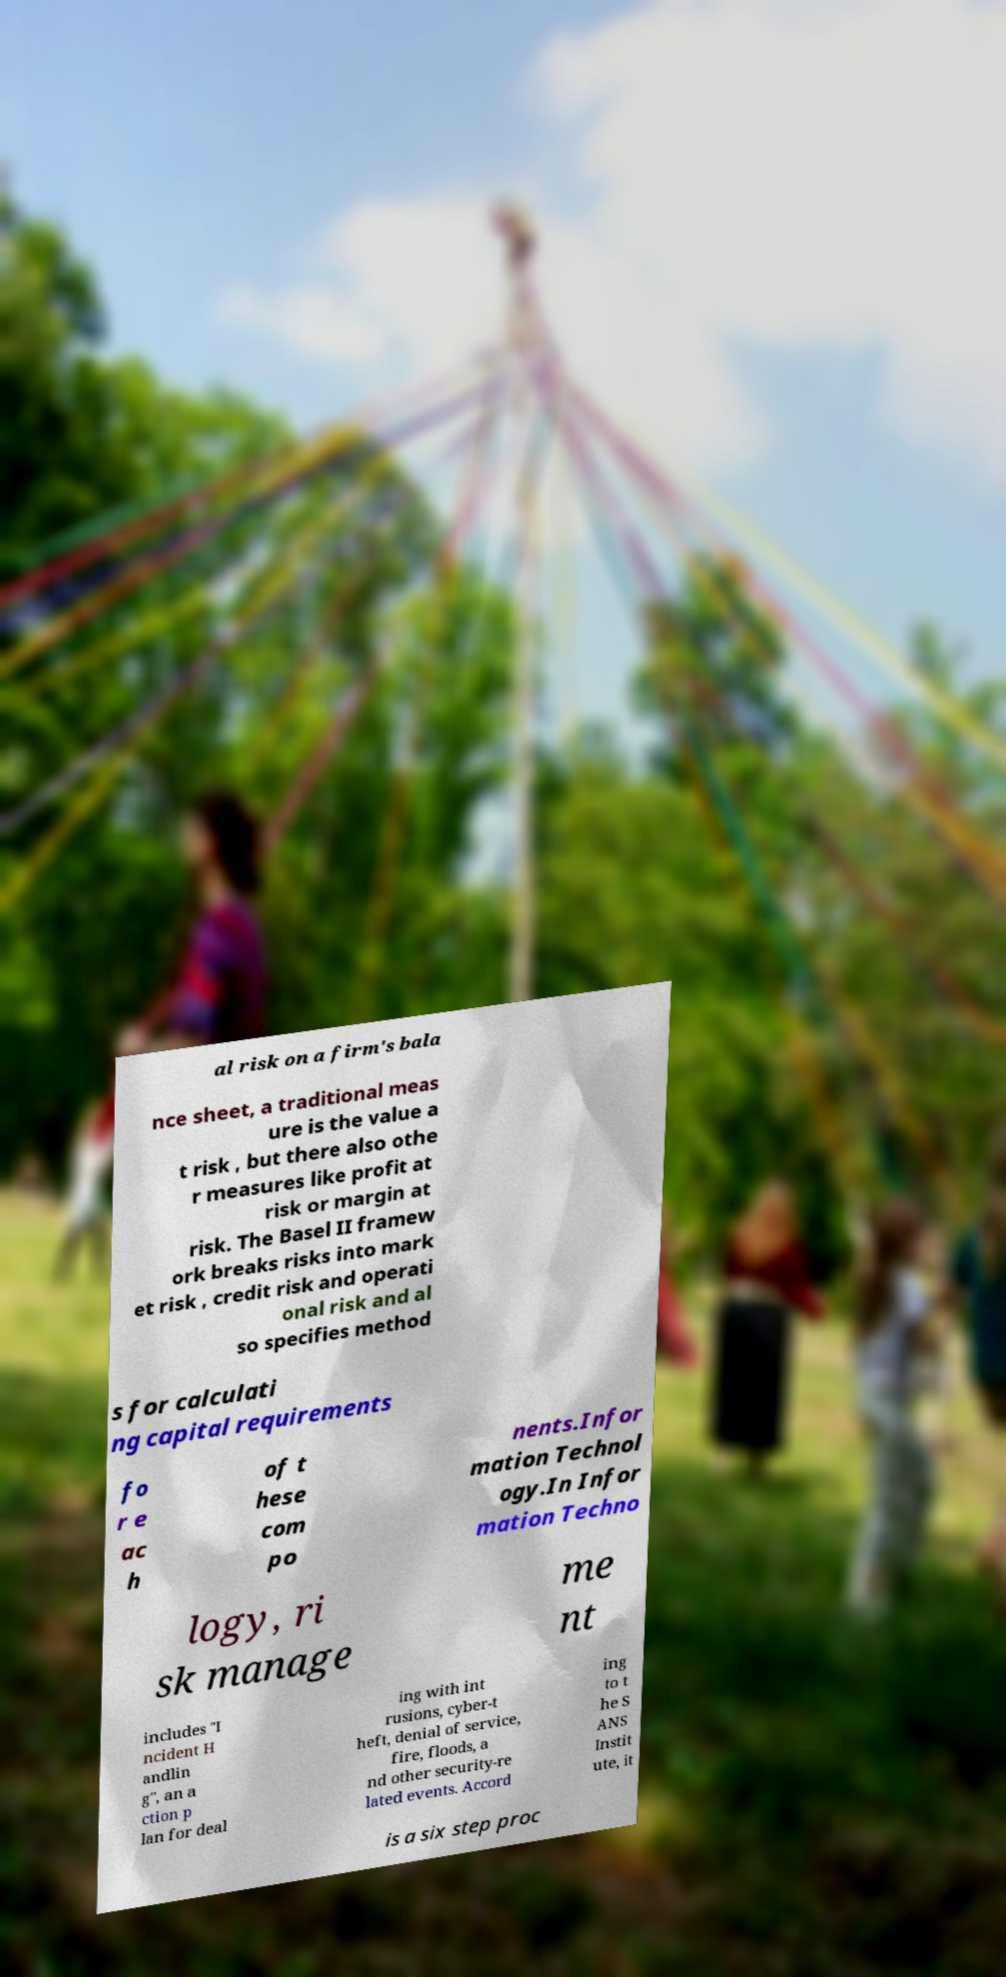For documentation purposes, I need the text within this image transcribed. Could you provide that? al risk on a firm's bala nce sheet, a traditional meas ure is the value a t risk , but there also othe r measures like profit at risk or margin at risk. The Basel II framew ork breaks risks into mark et risk , credit risk and operati onal risk and al so specifies method s for calculati ng capital requirements fo r e ac h of t hese com po nents.Infor mation Technol ogy.In Infor mation Techno logy, ri sk manage me nt includes "I ncident H andlin g", an a ction p lan for deal ing with int rusions, cyber-t heft, denial of service, fire, floods, a nd other security-re lated events. Accord ing to t he S ANS Instit ute, it is a six step proc 